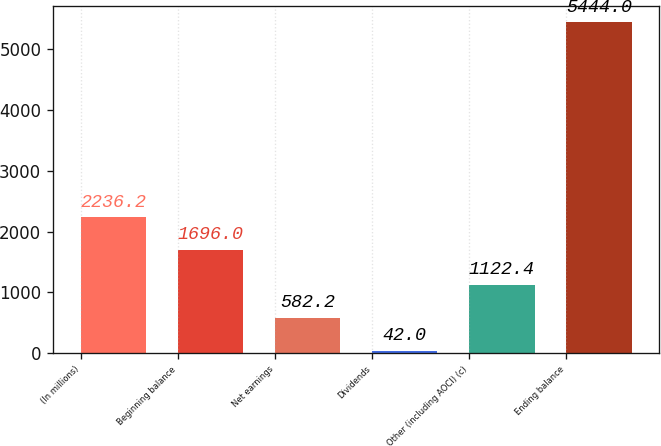<chart> <loc_0><loc_0><loc_500><loc_500><bar_chart><fcel>(In millions)<fcel>Beginning balance<fcel>Net earnings<fcel>Dividends<fcel>Other (including AOCI) (c)<fcel>Ending balance<nl><fcel>2236.2<fcel>1696<fcel>582.2<fcel>42<fcel>1122.4<fcel>5444<nl></chart> 